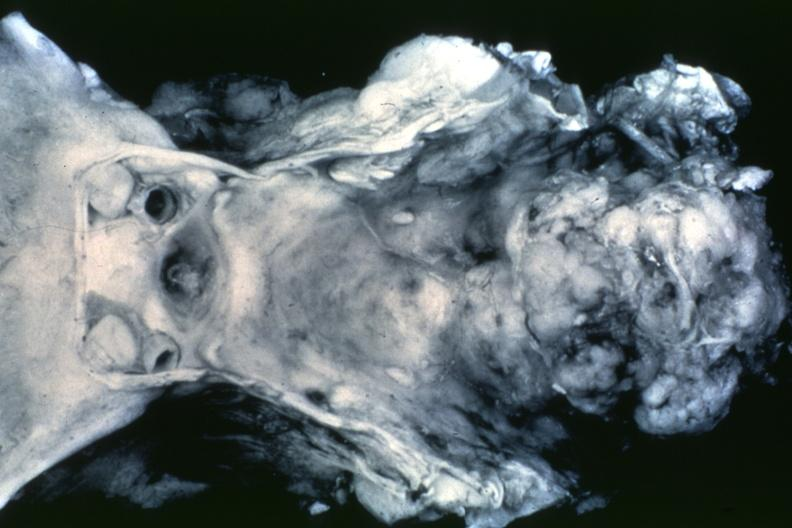s chordoma present?
Answer the question using a single word or phrase. Yes 